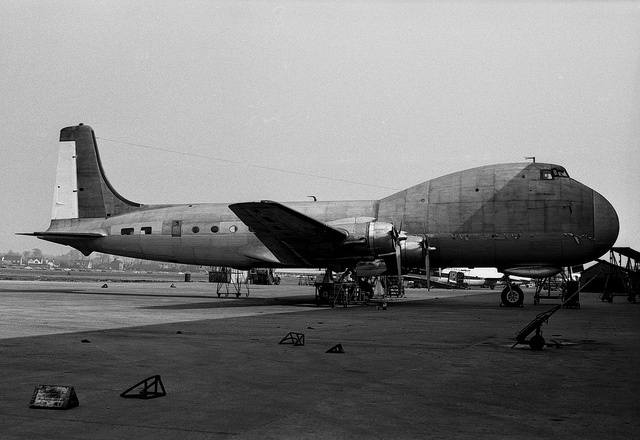Describe the objects in this image and their specific colors. I can see a airplane in lightgray, black, gray, and darkgray tones in this image. 